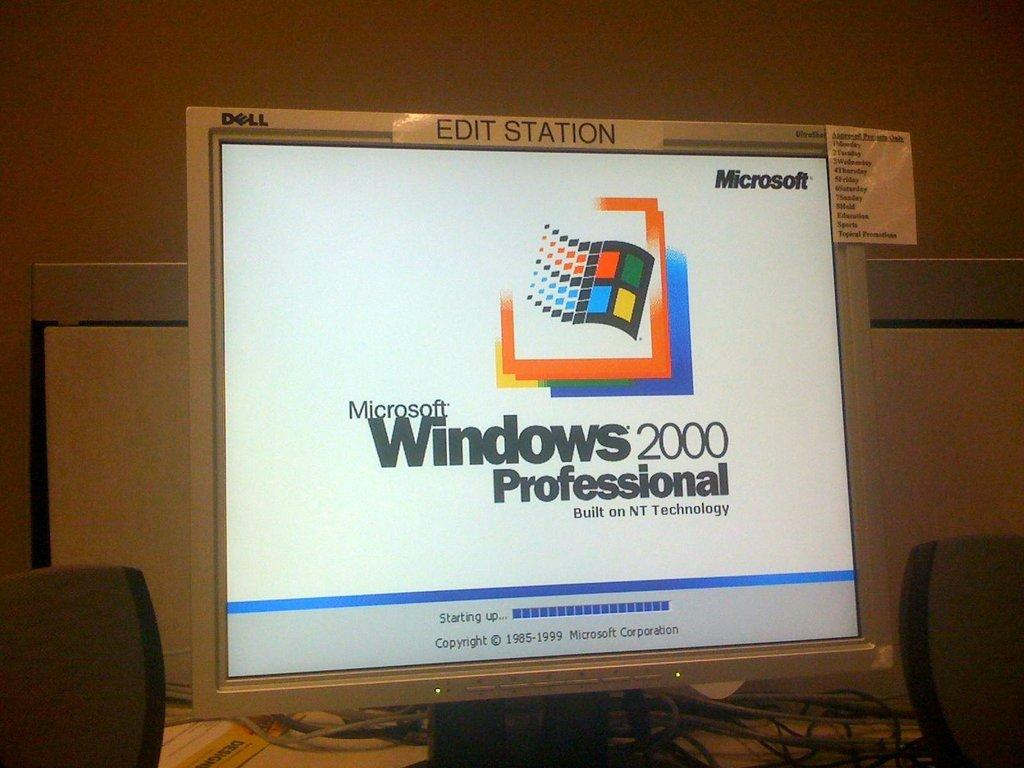<image>
Write a terse but informative summary of the picture. A computer is on with the display showing Microsoft Windows 2000 Professional with a logo. 